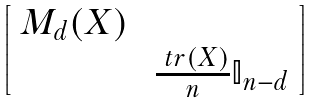<formula> <loc_0><loc_0><loc_500><loc_500>\begin{bmatrix} \ M _ { d } ( X ) \ \\ & \frac { \ t r ( X ) } { n } \mathbb { I } _ { n - d } \ \end{bmatrix}</formula> 